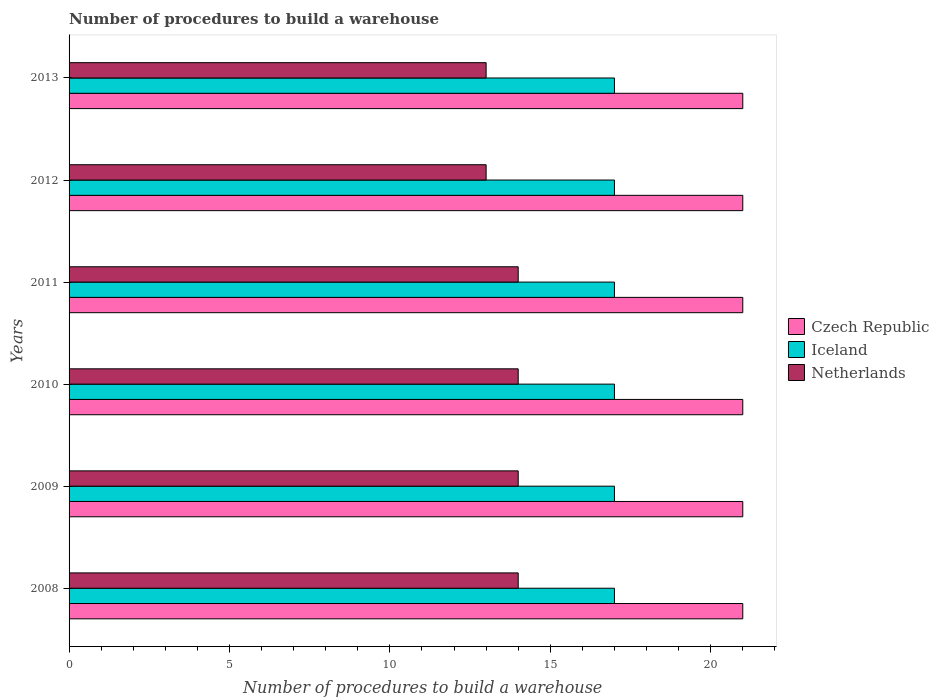How many groups of bars are there?
Offer a very short reply. 6. Are the number of bars on each tick of the Y-axis equal?
Ensure brevity in your answer.  Yes. How many bars are there on the 5th tick from the top?
Your response must be concise. 3. How many bars are there on the 1st tick from the bottom?
Keep it short and to the point. 3. What is the label of the 5th group of bars from the top?
Provide a short and direct response. 2009. What is the number of procedures to build a warehouse in in Iceland in 2010?
Provide a succinct answer. 17. Across all years, what is the maximum number of procedures to build a warehouse in in Czech Republic?
Your response must be concise. 21. Across all years, what is the minimum number of procedures to build a warehouse in in Netherlands?
Ensure brevity in your answer.  13. In which year was the number of procedures to build a warehouse in in Iceland maximum?
Make the answer very short. 2008. What is the total number of procedures to build a warehouse in in Netherlands in the graph?
Offer a terse response. 82. What is the difference between the number of procedures to build a warehouse in in Netherlands in 2011 and that in 2012?
Offer a terse response. 1. What is the difference between the number of procedures to build a warehouse in in Czech Republic in 2009 and the number of procedures to build a warehouse in in Netherlands in 2012?
Give a very brief answer. 8. In the year 2013, what is the difference between the number of procedures to build a warehouse in in Iceland and number of procedures to build a warehouse in in Netherlands?
Your answer should be compact. 4. What is the difference between the highest and the lowest number of procedures to build a warehouse in in Netherlands?
Ensure brevity in your answer.  1. In how many years, is the number of procedures to build a warehouse in in Iceland greater than the average number of procedures to build a warehouse in in Iceland taken over all years?
Your answer should be very brief. 0. Is the sum of the number of procedures to build a warehouse in in Netherlands in 2008 and 2012 greater than the maximum number of procedures to build a warehouse in in Iceland across all years?
Provide a short and direct response. Yes. What does the 3rd bar from the top in 2012 represents?
Offer a very short reply. Czech Republic. What does the 2nd bar from the bottom in 2013 represents?
Make the answer very short. Iceland. How many bars are there?
Offer a very short reply. 18. Are all the bars in the graph horizontal?
Offer a terse response. Yes. How many years are there in the graph?
Keep it short and to the point. 6. What is the difference between two consecutive major ticks on the X-axis?
Ensure brevity in your answer.  5. Does the graph contain any zero values?
Keep it short and to the point. No. Does the graph contain grids?
Offer a very short reply. No. Where does the legend appear in the graph?
Provide a succinct answer. Center right. How many legend labels are there?
Your answer should be very brief. 3. What is the title of the graph?
Provide a succinct answer. Number of procedures to build a warehouse. What is the label or title of the X-axis?
Ensure brevity in your answer.  Number of procedures to build a warehouse. What is the label or title of the Y-axis?
Provide a succinct answer. Years. What is the Number of procedures to build a warehouse of Czech Republic in 2008?
Your response must be concise. 21. What is the Number of procedures to build a warehouse in Iceland in 2008?
Your answer should be compact. 17. What is the Number of procedures to build a warehouse of Netherlands in 2008?
Provide a short and direct response. 14. What is the Number of procedures to build a warehouse in Czech Republic in 2009?
Keep it short and to the point. 21. What is the Number of procedures to build a warehouse of Czech Republic in 2010?
Your answer should be compact. 21. What is the Number of procedures to build a warehouse in Iceland in 2011?
Provide a succinct answer. 17. What is the Number of procedures to build a warehouse of Netherlands in 2011?
Offer a terse response. 14. What is the Number of procedures to build a warehouse of Iceland in 2013?
Offer a terse response. 17. Across all years, what is the maximum Number of procedures to build a warehouse of Czech Republic?
Provide a short and direct response. 21. Across all years, what is the maximum Number of procedures to build a warehouse of Iceland?
Provide a succinct answer. 17. Across all years, what is the maximum Number of procedures to build a warehouse in Netherlands?
Offer a very short reply. 14. Across all years, what is the minimum Number of procedures to build a warehouse in Iceland?
Provide a succinct answer. 17. Across all years, what is the minimum Number of procedures to build a warehouse of Netherlands?
Your answer should be compact. 13. What is the total Number of procedures to build a warehouse in Czech Republic in the graph?
Make the answer very short. 126. What is the total Number of procedures to build a warehouse in Iceland in the graph?
Your answer should be very brief. 102. What is the difference between the Number of procedures to build a warehouse of Czech Republic in 2008 and that in 2009?
Provide a short and direct response. 0. What is the difference between the Number of procedures to build a warehouse of Iceland in 2008 and that in 2009?
Your answer should be compact. 0. What is the difference between the Number of procedures to build a warehouse in Netherlands in 2008 and that in 2009?
Your response must be concise. 0. What is the difference between the Number of procedures to build a warehouse of Czech Republic in 2008 and that in 2010?
Your response must be concise. 0. What is the difference between the Number of procedures to build a warehouse of Iceland in 2008 and that in 2010?
Keep it short and to the point. 0. What is the difference between the Number of procedures to build a warehouse of Iceland in 2008 and that in 2012?
Your answer should be compact. 0. What is the difference between the Number of procedures to build a warehouse of Czech Republic in 2009 and that in 2010?
Give a very brief answer. 0. What is the difference between the Number of procedures to build a warehouse of Iceland in 2009 and that in 2010?
Keep it short and to the point. 0. What is the difference between the Number of procedures to build a warehouse of Czech Republic in 2009 and that in 2011?
Offer a very short reply. 0. What is the difference between the Number of procedures to build a warehouse of Netherlands in 2009 and that in 2011?
Ensure brevity in your answer.  0. What is the difference between the Number of procedures to build a warehouse of Iceland in 2009 and that in 2012?
Ensure brevity in your answer.  0. What is the difference between the Number of procedures to build a warehouse of Netherlands in 2009 and that in 2012?
Make the answer very short. 1. What is the difference between the Number of procedures to build a warehouse in Iceland in 2009 and that in 2013?
Your answer should be very brief. 0. What is the difference between the Number of procedures to build a warehouse in Czech Republic in 2010 and that in 2011?
Your response must be concise. 0. What is the difference between the Number of procedures to build a warehouse in Iceland in 2010 and that in 2011?
Your response must be concise. 0. What is the difference between the Number of procedures to build a warehouse in Czech Republic in 2010 and that in 2012?
Provide a succinct answer. 0. What is the difference between the Number of procedures to build a warehouse in Iceland in 2010 and that in 2012?
Your answer should be very brief. 0. What is the difference between the Number of procedures to build a warehouse in Netherlands in 2010 and that in 2012?
Your response must be concise. 1. What is the difference between the Number of procedures to build a warehouse in Iceland in 2010 and that in 2013?
Your answer should be very brief. 0. What is the difference between the Number of procedures to build a warehouse in Iceland in 2011 and that in 2012?
Make the answer very short. 0. What is the difference between the Number of procedures to build a warehouse of Netherlands in 2011 and that in 2012?
Offer a very short reply. 1. What is the difference between the Number of procedures to build a warehouse in Czech Republic in 2011 and that in 2013?
Give a very brief answer. 0. What is the difference between the Number of procedures to build a warehouse in Czech Republic in 2008 and the Number of procedures to build a warehouse in Iceland in 2009?
Provide a succinct answer. 4. What is the difference between the Number of procedures to build a warehouse in Iceland in 2008 and the Number of procedures to build a warehouse in Netherlands in 2009?
Your response must be concise. 3. What is the difference between the Number of procedures to build a warehouse in Czech Republic in 2008 and the Number of procedures to build a warehouse in Netherlands in 2010?
Your answer should be very brief. 7. What is the difference between the Number of procedures to build a warehouse in Iceland in 2008 and the Number of procedures to build a warehouse in Netherlands in 2010?
Make the answer very short. 3. What is the difference between the Number of procedures to build a warehouse of Czech Republic in 2008 and the Number of procedures to build a warehouse of Netherlands in 2011?
Ensure brevity in your answer.  7. What is the difference between the Number of procedures to build a warehouse in Iceland in 2008 and the Number of procedures to build a warehouse in Netherlands in 2011?
Give a very brief answer. 3. What is the difference between the Number of procedures to build a warehouse of Czech Republic in 2008 and the Number of procedures to build a warehouse of Netherlands in 2012?
Provide a short and direct response. 8. What is the difference between the Number of procedures to build a warehouse of Iceland in 2008 and the Number of procedures to build a warehouse of Netherlands in 2013?
Your answer should be compact. 4. What is the difference between the Number of procedures to build a warehouse in Czech Republic in 2009 and the Number of procedures to build a warehouse in Iceland in 2010?
Your answer should be very brief. 4. What is the difference between the Number of procedures to build a warehouse of Iceland in 2009 and the Number of procedures to build a warehouse of Netherlands in 2010?
Your response must be concise. 3. What is the difference between the Number of procedures to build a warehouse of Czech Republic in 2009 and the Number of procedures to build a warehouse of Netherlands in 2011?
Keep it short and to the point. 7. What is the difference between the Number of procedures to build a warehouse in Czech Republic in 2009 and the Number of procedures to build a warehouse in Iceland in 2012?
Your answer should be very brief. 4. What is the difference between the Number of procedures to build a warehouse in Czech Republic in 2009 and the Number of procedures to build a warehouse in Iceland in 2013?
Your answer should be very brief. 4. What is the difference between the Number of procedures to build a warehouse in Czech Republic in 2009 and the Number of procedures to build a warehouse in Netherlands in 2013?
Your answer should be very brief. 8. What is the difference between the Number of procedures to build a warehouse in Iceland in 2009 and the Number of procedures to build a warehouse in Netherlands in 2013?
Ensure brevity in your answer.  4. What is the difference between the Number of procedures to build a warehouse in Czech Republic in 2010 and the Number of procedures to build a warehouse in Iceland in 2011?
Your response must be concise. 4. What is the difference between the Number of procedures to build a warehouse in Czech Republic in 2010 and the Number of procedures to build a warehouse in Netherlands in 2011?
Keep it short and to the point. 7. What is the difference between the Number of procedures to build a warehouse of Czech Republic in 2010 and the Number of procedures to build a warehouse of Netherlands in 2012?
Offer a very short reply. 8. What is the difference between the Number of procedures to build a warehouse of Iceland in 2010 and the Number of procedures to build a warehouse of Netherlands in 2012?
Make the answer very short. 4. What is the difference between the Number of procedures to build a warehouse of Czech Republic in 2010 and the Number of procedures to build a warehouse of Iceland in 2013?
Your answer should be very brief. 4. What is the difference between the Number of procedures to build a warehouse of Czech Republic in 2010 and the Number of procedures to build a warehouse of Netherlands in 2013?
Provide a succinct answer. 8. What is the difference between the Number of procedures to build a warehouse in Czech Republic in 2011 and the Number of procedures to build a warehouse in Netherlands in 2012?
Offer a very short reply. 8. What is the difference between the Number of procedures to build a warehouse of Iceland in 2011 and the Number of procedures to build a warehouse of Netherlands in 2012?
Offer a very short reply. 4. What is the difference between the Number of procedures to build a warehouse of Czech Republic in 2011 and the Number of procedures to build a warehouse of Iceland in 2013?
Offer a very short reply. 4. What is the difference between the Number of procedures to build a warehouse of Czech Republic in 2011 and the Number of procedures to build a warehouse of Netherlands in 2013?
Make the answer very short. 8. What is the difference between the Number of procedures to build a warehouse in Czech Republic in 2012 and the Number of procedures to build a warehouse in Netherlands in 2013?
Ensure brevity in your answer.  8. What is the average Number of procedures to build a warehouse of Iceland per year?
Your answer should be compact. 17. What is the average Number of procedures to build a warehouse in Netherlands per year?
Your response must be concise. 13.67. In the year 2008, what is the difference between the Number of procedures to build a warehouse of Czech Republic and Number of procedures to build a warehouse of Netherlands?
Offer a very short reply. 7. In the year 2009, what is the difference between the Number of procedures to build a warehouse of Czech Republic and Number of procedures to build a warehouse of Iceland?
Keep it short and to the point. 4. In the year 2010, what is the difference between the Number of procedures to build a warehouse of Czech Republic and Number of procedures to build a warehouse of Netherlands?
Keep it short and to the point. 7. In the year 2011, what is the difference between the Number of procedures to build a warehouse in Czech Republic and Number of procedures to build a warehouse in Netherlands?
Ensure brevity in your answer.  7. In the year 2011, what is the difference between the Number of procedures to build a warehouse of Iceland and Number of procedures to build a warehouse of Netherlands?
Provide a short and direct response. 3. In the year 2012, what is the difference between the Number of procedures to build a warehouse of Iceland and Number of procedures to build a warehouse of Netherlands?
Give a very brief answer. 4. In the year 2013, what is the difference between the Number of procedures to build a warehouse of Iceland and Number of procedures to build a warehouse of Netherlands?
Your answer should be compact. 4. What is the ratio of the Number of procedures to build a warehouse in Czech Republic in 2008 to that in 2009?
Give a very brief answer. 1. What is the ratio of the Number of procedures to build a warehouse of Netherlands in 2008 to that in 2009?
Your answer should be compact. 1. What is the ratio of the Number of procedures to build a warehouse in Iceland in 2008 to that in 2010?
Offer a terse response. 1. What is the ratio of the Number of procedures to build a warehouse of Czech Republic in 2008 to that in 2011?
Keep it short and to the point. 1. What is the ratio of the Number of procedures to build a warehouse in Netherlands in 2008 to that in 2011?
Ensure brevity in your answer.  1. What is the ratio of the Number of procedures to build a warehouse of Czech Republic in 2008 to that in 2012?
Provide a succinct answer. 1. What is the ratio of the Number of procedures to build a warehouse of Netherlands in 2008 to that in 2012?
Your answer should be compact. 1.08. What is the ratio of the Number of procedures to build a warehouse of Czech Republic in 2008 to that in 2013?
Your answer should be compact. 1. What is the ratio of the Number of procedures to build a warehouse in Netherlands in 2008 to that in 2013?
Make the answer very short. 1.08. What is the ratio of the Number of procedures to build a warehouse in Iceland in 2009 to that in 2010?
Offer a terse response. 1. What is the ratio of the Number of procedures to build a warehouse in Netherlands in 2009 to that in 2010?
Make the answer very short. 1. What is the ratio of the Number of procedures to build a warehouse in Czech Republic in 2009 to that in 2012?
Provide a short and direct response. 1. What is the ratio of the Number of procedures to build a warehouse of Iceland in 2009 to that in 2012?
Keep it short and to the point. 1. What is the ratio of the Number of procedures to build a warehouse in Netherlands in 2009 to that in 2012?
Offer a very short reply. 1.08. What is the ratio of the Number of procedures to build a warehouse of Czech Republic in 2009 to that in 2013?
Your answer should be very brief. 1. What is the ratio of the Number of procedures to build a warehouse of Czech Republic in 2010 to that in 2011?
Provide a short and direct response. 1. What is the ratio of the Number of procedures to build a warehouse in Iceland in 2010 to that in 2011?
Your answer should be compact. 1. What is the ratio of the Number of procedures to build a warehouse of Netherlands in 2010 to that in 2011?
Your answer should be compact. 1. What is the ratio of the Number of procedures to build a warehouse of Czech Republic in 2010 to that in 2012?
Give a very brief answer. 1. What is the ratio of the Number of procedures to build a warehouse in Iceland in 2010 to that in 2012?
Your answer should be very brief. 1. What is the ratio of the Number of procedures to build a warehouse of Netherlands in 2010 to that in 2012?
Offer a very short reply. 1.08. What is the ratio of the Number of procedures to build a warehouse of Czech Republic in 2010 to that in 2013?
Keep it short and to the point. 1. What is the ratio of the Number of procedures to build a warehouse in Iceland in 2010 to that in 2013?
Your answer should be compact. 1. What is the ratio of the Number of procedures to build a warehouse of Netherlands in 2010 to that in 2013?
Give a very brief answer. 1.08. What is the ratio of the Number of procedures to build a warehouse in Czech Republic in 2011 to that in 2012?
Give a very brief answer. 1. What is the ratio of the Number of procedures to build a warehouse of Netherlands in 2011 to that in 2012?
Keep it short and to the point. 1.08. What is the ratio of the Number of procedures to build a warehouse in Czech Republic in 2011 to that in 2013?
Provide a short and direct response. 1. What is the ratio of the Number of procedures to build a warehouse in Iceland in 2011 to that in 2013?
Provide a short and direct response. 1. What is the ratio of the Number of procedures to build a warehouse of Netherlands in 2012 to that in 2013?
Give a very brief answer. 1. What is the difference between the highest and the second highest Number of procedures to build a warehouse in Czech Republic?
Provide a short and direct response. 0. What is the difference between the highest and the second highest Number of procedures to build a warehouse in Netherlands?
Your answer should be very brief. 0. What is the difference between the highest and the lowest Number of procedures to build a warehouse in Iceland?
Make the answer very short. 0. 